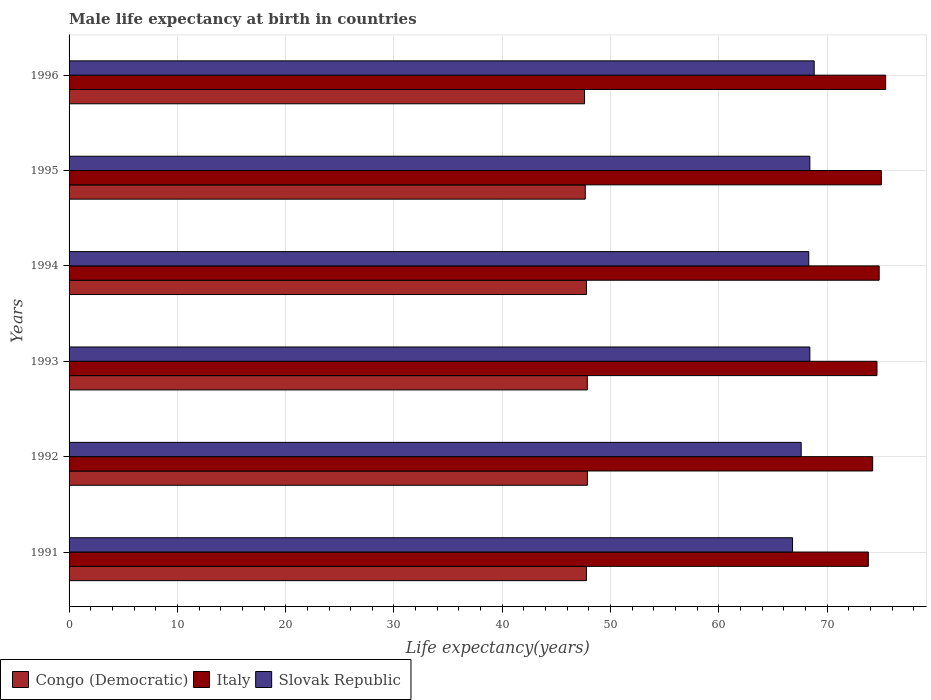How many groups of bars are there?
Provide a succinct answer. 6. Are the number of bars per tick equal to the number of legend labels?
Provide a short and direct response. Yes. Are the number of bars on each tick of the Y-axis equal?
Give a very brief answer. Yes. How many bars are there on the 3rd tick from the top?
Provide a succinct answer. 3. How many bars are there on the 2nd tick from the bottom?
Ensure brevity in your answer.  3. In how many cases, is the number of bars for a given year not equal to the number of legend labels?
Your response must be concise. 0. What is the male life expectancy at birth in Slovak Republic in 1994?
Your answer should be compact. 68.3. Across all years, what is the maximum male life expectancy at birth in Congo (Democratic)?
Your answer should be compact. 47.86. Across all years, what is the minimum male life expectancy at birth in Congo (Democratic)?
Your answer should be compact. 47.59. In which year was the male life expectancy at birth in Slovak Republic minimum?
Give a very brief answer. 1991. What is the total male life expectancy at birth in Congo (Democratic) in the graph?
Provide a succinct answer. 286.51. What is the difference between the male life expectancy at birth in Congo (Democratic) in 1991 and that in 1993?
Your response must be concise. -0.08. What is the difference between the male life expectancy at birth in Italy in 1992 and the male life expectancy at birth in Congo (Democratic) in 1993?
Your response must be concise. 26.35. What is the average male life expectancy at birth in Congo (Democratic) per year?
Provide a short and direct response. 47.75. In the year 1991, what is the difference between the male life expectancy at birth in Congo (Democratic) and male life expectancy at birth in Italy?
Give a very brief answer. -26.03. In how many years, is the male life expectancy at birth in Italy greater than 6 years?
Your response must be concise. 6. What is the ratio of the male life expectancy at birth in Congo (Democratic) in 1993 to that in 1994?
Your response must be concise. 1. Is the male life expectancy at birth in Italy in 1993 less than that in 1996?
Your answer should be very brief. Yes. What is the difference between the highest and the second highest male life expectancy at birth in Slovak Republic?
Provide a short and direct response. 0.4. What is the difference between the highest and the lowest male life expectancy at birth in Congo (Democratic)?
Your answer should be compact. 0.26. In how many years, is the male life expectancy at birth in Slovak Republic greater than the average male life expectancy at birth in Slovak Republic taken over all years?
Your answer should be very brief. 4. Is the sum of the male life expectancy at birth in Italy in 1992 and 1996 greater than the maximum male life expectancy at birth in Congo (Democratic) across all years?
Your response must be concise. Yes. What does the 2nd bar from the top in 1994 represents?
Provide a succinct answer. Italy. What does the 2nd bar from the bottom in 1992 represents?
Make the answer very short. Italy. How many bars are there?
Make the answer very short. 18. Does the graph contain any zero values?
Provide a short and direct response. No. Where does the legend appear in the graph?
Provide a short and direct response. Bottom left. What is the title of the graph?
Provide a short and direct response. Male life expectancy at birth in countries. What is the label or title of the X-axis?
Offer a terse response. Life expectancy(years). What is the label or title of the Y-axis?
Provide a succinct answer. Years. What is the Life expectancy(years) of Congo (Democratic) in 1991?
Provide a succinct answer. 47.77. What is the Life expectancy(years) in Italy in 1991?
Your answer should be very brief. 73.8. What is the Life expectancy(years) of Slovak Republic in 1991?
Provide a short and direct response. 66.8. What is the Life expectancy(years) of Congo (Democratic) in 1992?
Make the answer very short. 47.86. What is the Life expectancy(years) in Italy in 1992?
Keep it short and to the point. 74.2. What is the Life expectancy(years) in Slovak Republic in 1992?
Offer a very short reply. 67.6. What is the Life expectancy(years) in Congo (Democratic) in 1993?
Make the answer very short. 47.85. What is the Life expectancy(years) of Italy in 1993?
Ensure brevity in your answer.  74.6. What is the Life expectancy(years) of Slovak Republic in 1993?
Provide a succinct answer. 68.4. What is the Life expectancy(years) in Congo (Democratic) in 1994?
Your response must be concise. 47.77. What is the Life expectancy(years) in Italy in 1994?
Provide a short and direct response. 74.8. What is the Life expectancy(years) in Slovak Republic in 1994?
Provide a short and direct response. 68.3. What is the Life expectancy(years) of Congo (Democratic) in 1995?
Offer a very short reply. 47.66. What is the Life expectancy(years) of Slovak Republic in 1995?
Your answer should be very brief. 68.4. What is the Life expectancy(years) in Congo (Democratic) in 1996?
Offer a very short reply. 47.59. What is the Life expectancy(years) of Italy in 1996?
Give a very brief answer. 75.4. What is the Life expectancy(years) of Slovak Republic in 1996?
Ensure brevity in your answer.  68.8. Across all years, what is the maximum Life expectancy(years) in Congo (Democratic)?
Offer a terse response. 47.86. Across all years, what is the maximum Life expectancy(years) in Italy?
Keep it short and to the point. 75.4. Across all years, what is the maximum Life expectancy(years) of Slovak Republic?
Offer a terse response. 68.8. Across all years, what is the minimum Life expectancy(years) in Congo (Democratic)?
Offer a very short reply. 47.59. Across all years, what is the minimum Life expectancy(years) in Italy?
Make the answer very short. 73.8. Across all years, what is the minimum Life expectancy(years) of Slovak Republic?
Offer a terse response. 66.8. What is the total Life expectancy(years) in Congo (Democratic) in the graph?
Your answer should be very brief. 286.51. What is the total Life expectancy(years) in Italy in the graph?
Give a very brief answer. 447.8. What is the total Life expectancy(years) of Slovak Republic in the graph?
Provide a short and direct response. 408.3. What is the difference between the Life expectancy(years) of Congo (Democratic) in 1991 and that in 1992?
Offer a very short reply. -0.09. What is the difference between the Life expectancy(years) in Italy in 1991 and that in 1992?
Keep it short and to the point. -0.4. What is the difference between the Life expectancy(years) of Congo (Democratic) in 1991 and that in 1993?
Your answer should be very brief. -0.08. What is the difference between the Life expectancy(years) in Slovak Republic in 1991 and that in 1993?
Keep it short and to the point. -1.6. What is the difference between the Life expectancy(years) of Congo (Democratic) in 1991 and that in 1994?
Ensure brevity in your answer.  0. What is the difference between the Life expectancy(years) of Italy in 1991 and that in 1994?
Your answer should be compact. -1. What is the difference between the Life expectancy(years) in Congo (Democratic) in 1991 and that in 1995?
Your answer should be compact. 0.11. What is the difference between the Life expectancy(years) in Italy in 1991 and that in 1995?
Ensure brevity in your answer.  -1.2. What is the difference between the Life expectancy(years) of Slovak Republic in 1991 and that in 1995?
Provide a short and direct response. -1.6. What is the difference between the Life expectancy(years) in Congo (Democratic) in 1991 and that in 1996?
Provide a short and direct response. 0.18. What is the difference between the Life expectancy(years) in Italy in 1991 and that in 1996?
Make the answer very short. -1.6. What is the difference between the Life expectancy(years) of Slovak Republic in 1991 and that in 1996?
Give a very brief answer. -2. What is the difference between the Life expectancy(years) in Congo (Democratic) in 1992 and that in 1993?
Provide a short and direct response. 0.01. What is the difference between the Life expectancy(years) in Congo (Democratic) in 1992 and that in 1994?
Provide a short and direct response. 0.09. What is the difference between the Life expectancy(years) of Slovak Republic in 1992 and that in 1994?
Make the answer very short. -0.7. What is the difference between the Life expectancy(years) of Congo (Democratic) in 1992 and that in 1995?
Your response must be concise. 0.2. What is the difference between the Life expectancy(years) of Slovak Republic in 1992 and that in 1995?
Make the answer very short. -0.8. What is the difference between the Life expectancy(years) in Congo (Democratic) in 1992 and that in 1996?
Give a very brief answer. 0.26. What is the difference between the Life expectancy(years) in Congo (Democratic) in 1993 and that in 1994?
Make the answer very short. 0.08. What is the difference between the Life expectancy(years) in Italy in 1993 and that in 1994?
Your answer should be very brief. -0.2. What is the difference between the Life expectancy(years) of Congo (Democratic) in 1993 and that in 1995?
Make the answer very short. 0.19. What is the difference between the Life expectancy(years) in Slovak Republic in 1993 and that in 1995?
Your response must be concise. 0. What is the difference between the Life expectancy(years) in Congo (Democratic) in 1993 and that in 1996?
Keep it short and to the point. 0.26. What is the difference between the Life expectancy(years) of Italy in 1993 and that in 1996?
Give a very brief answer. -0.8. What is the difference between the Life expectancy(years) in Congo (Democratic) in 1994 and that in 1995?
Your response must be concise. 0.11. What is the difference between the Life expectancy(years) in Italy in 1994 and that in 1995?
Make the answer very short. -0.2. What is the difference between the Life expectancy(years) of Slovak Republic in 1994 and that in 1995?
Give a very brief answer. -0.1. What is the difference between the Life expectancy(years) of Congo (Democratic) in 1994 and that in 1996?
Ensure brevity in your answer.  0.17. What is the difference between the Life expectancy(years) in Italy in 1994 and that in 1996?
Make the answer very short. -0.6. What is the difference between the Life expectancy(years) of Slovak Republic in 1994 and that in 1996?
Provide a succinct answer. -0.5. What is the difference between the Life expectancy(years) of Congo (Democratic) in 1995 and that in 1996?
Offer a terse response. 0.07. What is the difference between the Life expectancy(years) of Congo (Democratic) in 1991 and the Life expectancy(years) of Italy in 1992?
Your response must be concise. -26.43. What is the difference between the Life expectancy(years) in Congo (Democratic) in 1991 and the Life expectancy(years) in Slovak Republic in 1992?
Your response must be concise. -19.83. What is the difference between the Life expectancy(years) in Congo (Democratic) in 1991 and the Life expectancy(years) in Italy in 1993?
Keep it short and to the point. -26.83. What is the difference between the Life expectancy(years) of Congo (Democratic) in 1991 and the Life expectancy(years) of Slovak Republic in 1993?
Make the answer very short. -20.63. What is the difference between the Life expectancy(years) in Congo (Democratic) in 1991 and the Life expectancy(years) in Italy in 1994?
Give a very brief answer. -27.03. What is the difference between the Life expectancy(years) of Congo (Democratic) in 1991 and the Life expectancy(years) of Slovak Republic in 1994?
Your answer should be compact. -20.53. What is the difference between the Life expectancy(years) of Italy in 1991 and the Life expectancy(years) of Slovak Republic in 1994?
Provide a short and direct response. 5.5. What is the difference between the Life expectancy(years) in Congo (Democratic) in 1991 and the Life expectancy(years) in Italy in 1995?
Provide a succinct answer. -27.23. What is the difference between the Life expectancy(years) in Congo (Democratic) in 1991 and the Life expectancy(years) in Slovak Republic in 1995?
Your answer should be very brief. -20.63. What is the difference between the Life expectancy(years) in Italy in 1991 and the Life expectancy(years) in Slovak Republic in 1995?
Your answer should be very brief. 5.4. What is the difference between the Life expectancy(years) of Congo (Democratic) in 1991 and the Life expectancy(years) of Italy in 1996?
Your answer should be compact. -27.63. What is the difference between the Life expectancy(years) of Congo (Democratic) in 1991 and the Life expectancy(years) of Slovak Republic in 1996?
Keep it short and to the point. -21.03. What is the difference between the Life expectancy(years) of Congo (Democratic) in 1992 and the Life expectancy(years) of Italy in 1993?
Keep it short and to the point. -26.74. What is the difference between the Life expectancy(years) of Congo (Democratic) in 1992 and the Life expectancy(years) of Slovak Republic in 1993?
Provide a succinct answer. -20.54. What is the difference between the Life expectancy(years) of Congo (Democratic) in 1992 and the Life expectancy(years) of Italy in 1994?
Give a very brief answer. -26.94. What is the difference between the Life expectancy(years) in Congo (Democratic) in 1992 and the Life expectancy(years) in Slovak Republic in 1994?
Your answer should be very brief. -20.44. What is the difference between the Life expectancy(years) of Italy in 1992 and the Life expectancy(years) of Slovak Republic in 1994?
Provide a short and direct response. 5.9. What is the difference between the Life expectancy(years) in Congo (Democratic) in 1992 and the Life expectancy(years) in Italy in 1995?
Keep it short and to the point. -27.14. What is the difference between the Life expectancy(years) of Congo (Democratic) in 1992 and the Life expectancy(years) of Slovak Republic in 1995?
Provide a succinct answer. -20.54. What is the difference between the Life expectancy(years) of Italy in 1992 and the Life expectancy(years) of Slovak Republic in 1995?
Ensure brevity in your answer.  5.8. What is the difference between the Life expectancy(years) of Congo (Democratic) in 1992 and the Life expectancy(years) of Italy in 1996?
Ensure brevity in your answer.  -27.54. What is the difference between the Life expectancy(years) of Congo (Democratic) in 1992 and the Life expectancy(years) of Slovak Republic in 1996?
Make the answer very short. -20.94. What is the difference between the Life expectancy(years) in Italy in 1992 and the Life expectancy(years) in Slovak Republic in 1996?
Provide a succinct answer. 5.4. What is the difference between the Life expectancy(years) in Congo (Democratic) in 1993 and the Life expectancy(years) in Italy in 1994?
Give a very brief answer. -26.95. What is the difference between the Life expectancy(years) in Congo (Democratic) in 1993 and the Life expectancy(years) in Slovak Republic in 1994?
Make the answer very short. -20.45. What is the difference between the Life expectancy(years) in Italy in 1993 and the Life expectancy(years) in Slovak Republic in 1994?
Keep it short and to the point. 6.3. What is the difference between the Life expectancy(years) of Congo (Democratic) in 1993 and the Life expectancy(years) of Italy in 1995?
Offer a terse response. -27.15. What is the difference between the Life expectancy(years) of Congo (Democratic) in 1993 and the Life expectancy(years) of Slovak Republic in 1995?
Your answer should be compact. -20.55. What is the difference between the Life expectancy(years) in Congo (Democratic) in 1993 and the Life expectancy(years) in Italy in 1996?
Provide a short and direct response. -27.55. What is the difference between the Life expectancy(years) in Congo (Democratic) in 1993 and the Life expectancy(years) in Slovak Republic in 1996?
Give a very brief answer. -20.95. What is the difference between the Life expectancy(years) in Congo (Democratic) in 1994 and the Life expectancy(years) in Italy in 1995?
Keep it short and to the point. -27.23. What is the difference between the Life expectancy(years) in Congo (Democratic) in 1994 and the Life expectancy(years) in Slovak Republic in 1995?
Make the answer very short. -20.63. What is the difference between the Life expectancy(years) of Congo (Democratic) in 1994 and the Life expectancy(years) of Italy in 1996?
Keep it short and to the point. -27.63. What is the difference between the Life expectancy(years) in Congo (Democratic) in 1994 and the Life expectancy(years) in Slovak Republic in 1996?
Provide a succinct answer. -21.03. What is the difference between the Life expectancy(years) in Italy in 1994 and the Life expectancy(years) in Slovak Republic in 1996?
Provide a short and direct response. 6. What is the difference between the Life expectancy(years) in Congo (Democratic) in 1995 and the Life expectancy(years) in Italy in 1996?
Your response must be concise. -27.74. What is the difference between the Life expectancy(years) in Congo (Democratic) in 1995 and the Life expectancy(years) in Slovak Republic in 1996?
Provide a succinct answer. -21.14. What is the difference between the Life expectancy(years) of Italy in 1995 and the Life expectancy(years) of Slovak Republic in 1996?
Keep it short and to the point. 6.2. What is the average Life expectancy(years) in Congo (Democratic) per year?
Your response must be concise. 47.75. What is the average Life expectancy(years) of Italy per year?
Make the answer very short. 74.63. What is the average Life expectancy(years) in Slovak Republic per year?
Your response must be concise. 68.05. In the year 1991, what is the difference between the Life expectancy(years) in Congo (Democratic) and Life expectancy(years) in Italy?
Offer a terse response. -26.03. In the year 1991, what is the difference between the Life expectancy(years) in Congo (Democratic) and Life expectancy(years) in Slovak Republic?
Your answer should be compact. -19.03. In the year 1991, what is the difference between the Life expectancy(years) in Italy and Life expectancy(years) in Slovak Republic?
Give a very brief answer. 7. In the year 1992, what is the difference between the Life expectancy(years) in Congo (Democratic) and Life expectancy(years) in Italy?
Your answer should be compact. -26.34. In the year 1992, what is the difference between the Life expectancy(years) of Congo (Democratic) and Life expectancy(years) of Slovak Republic?
Make the answer very short. -19.74. In the year 1992, what is the difference between the Life expectancy(years) in Italy and Life expectancy(years) in Slovak Republic?
Offer a terse response. 6.6. In the year 1993, what is the difference between the Life expectancy(years) in Congo (Democratic) and Life expectancy(years) in Italy?
Give a very brief answer. -26.75. In the year 1993, what is the difference between the Life expectancy(years) in Congo (Democratic) and Life expectancy(years) in Slovak Republic?
Your answer should be compact. -20.55. In the year 1994, what is the difference between the Life expectancy(years) of Congo (Democratic) and Life expectancy(years) of Italy?
Your answer should be very brief. -27.03. In the year 1994, what is the difference between the Life expectancy(years) of Congo (Democratic) and Life expectancy(years) of Slovak Republic?
Provide a succinct answer. -20.53. In the year 1994, what is the difference between the Life expectancy(years) in Italy and Life expectancy(years) in Slovak Republic?
Your answer should be compact. 6.5. In the year 1995, what is the difference between the Life expectancy(years) of Congo (Democratic) and Life expectancy(years) of Italy?
Make the answer very short. -27.34. In the year 1995, what is the difference between the Life expectancy(years) of Congo (Democratic) and Life expectancy(years) of Slovak Republic?
Ensure brevity in your answer.  -20.74. In the year 1995, what is the difference between the Life expectancy(years) of Italy and Life expectancy(years) of Slovak Republic?
Your answer should be very brief. 6.6. In the year 1996, what is the difference between the Life expectancy(years) of Congo (Democratic) and Life expectancy(years) of Italy?
Provide a succinct answer. -27.8. In the year 1996, what is the difference between the Life expectancy(years) in Congo (Democratic) and Life expectancy(years) in Slovak Republic?
Provide a short and direct response. -21.2. What is the ratio of the Life expectancy(years) in Congo (Democratic) in 1991 to that in 1992?
Give a very brief answer. 1. What is the ratio of the Life expectancy(years) in Italy in 1991 to that in 1992?
Your response must be concise. 0.99. What is the ratio of the Life expectancy(years) in Slovak Republic in 1991 to that in 1992?
Your answer should be very brief. 0.99. What is the ratio of the Life expectancy(years) of Congo (Democratic) in 1991 to that in 1993?
Your answer should be compact. 1. What is the ratio of the Life expectancy(years) of Italy in 1991 to that in 1993?
Ensure brevity in your answer.  0.99. What is the ratio of the Life expectancy(years) in Slovak Republic in 1991 to that in 1993?
Make the answer very short. 0.98. What is the ratio of the Life expectancy(years) of Congo (Democratic) in 1991 to that in 1994?
Your response must be concise. 1. What is the ratio of the Life expectancy(years) of Italy in 1991 to that in 1994?
Offer a very short reply. 0.99. What is the ratio of the Life expectancy(years) of Italy in 1991 to that in 1995?
Offer a very short reply. 0.98. What is the ratio of the Life expectancy(years) in Slovak Republic in 1991 to that in 1995?
Make the answer very short. 0.98. What is the ratio of the Life expectancy(years) of Congo (Democratic) in 1991 to that in 1996?
Offer a terse response. 1. What is the ratio of the Life expectancy(years) in Italy in 1991 to that in 1996?
Your answer should be very brief. 0.98. What is the ratio of the Life expectancy(years) in Slovak Republic in 1991 to that in 1996?
Provide a short and direct response. 0.97. What is the ratio of the Life expectancy(years) of Congo (Democratic) in 1992 to that in 1993?
Your answer should be compact. 1. What is the ratio of the Life expectancy(years) of Slovak Republic in 1992 to that in 1993?
Keep it short and to the point. 0.99. What is the ratio of the Life expectancy(years) in Congo (Democratic) in 1992 to that in 1994?
Offer a terse response. 1. What is the ratio of the Life expectancy(years) in Italy in 1992 to that in 1994?
Offer a terse response. 0.99. What is the ratio of the Life expectancy(years) of Slovak Republic in 1992 to that in 1994?
Keep it short and to the point. 0.99. What is the ratio of the Life expectancy(years) of Congo (Democratic) in 1992 to that in 1995?
Provide a succinct answer. 1. What is the ratio of the Life expectancy(years) in Italy in 1992 to that in 1995?
Provide a succinct answer. 0.99. What is the ratio of the Life expectancy(years) in Slovak Republic in 1992 to that in 1995?
Give a very brief answer. 0.99. What is the ratio of the Life expectancy(years) in Italy in 1992 to that in 1996?
Make the answer very short. 0.98. What is the ratio of the Life expectancy(years) in Slovak Republic in 1992 to that in 1996?
Provide a succinct answer. 0.98. What is the ratio of the Life expectancy(years) of Congo (Democratic) in 1993 to that in 1995?
Your response must be concise. 1. What is the ratio of the Life expectancy(years) of Slovak Republic in 1993 to that in 1995?
Your answer should be compact. 1. What is the ratio of the Life expectancy(years) in Congo (Democratic) in 1993 to that in 1996?
Ensure brevity in your answer.  1.01. What is the ratio of the Life expectancy(years) of Italy in 1993 to that in 1996?
Your response must be concise. 0.99. What is the ratio of the Life expectancy(years) in Slovak Republic in 1993 to that in 1996?
Make the answer very short. 0.99. What is the ratio of the Life expectancy(years) of Italy in 1994 to that in 1995?
Provide a succinct answer. 1. What is the ratio of the Life expectancy(years) in Slovak Republic in 1994 to that in 1995?
Give a very brief answer. 1. What is the ratio of the Life expectancy(years) of Slovak Republic in 1995 to that in 1996?
Your answer should be compact. 0.99. What is the difference between the highest and the second highest Life expectancy(years) of Congo (Democratic)?
Offer a terse response. 0.01. What is the difference between the highest and the second highest Life expectancy(years) of Italy?
Your response must be concise. 0.4. What is the difference between the highest and the second highest Life expectancy(years) of Slovak Republic?
Keep it short and to the point. 0.4. What is the difference between the highest and the lowest Life expectancy(years) of Congo (Democratic)?
Your response must be concise. 0.26. What is the difference between the highest and the lowest Life expectancy(years) in Slovak Republic?
Your answer should be very brief. 2. 